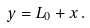<formula> <loc_0><loc_0><loc_500><loc_500>y = L _ { 0 } + x \, .</formula> 